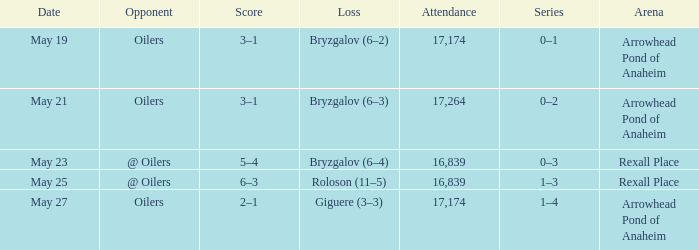Which attendance involves an antagonist of @ oilers, and a date of may 25? 16839.0. 